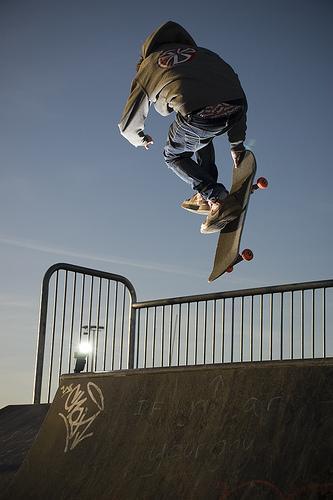How many skateboards are there?
Give a very brief answer. 1. How many baby giraffes are in the picture?
Give a very brief answer. 0. 